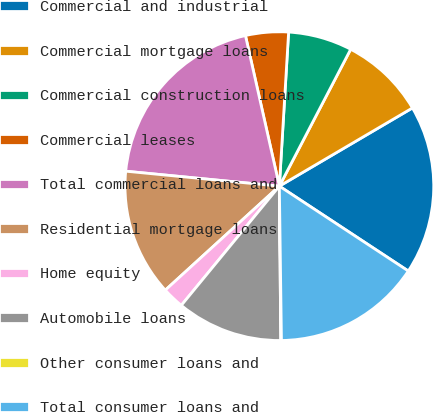<chart> <loc_0><loc_0><loc_500><loc_500><pie_chart><fcel>Commercial and industrial<fcel>Commercial mortgage loans<fcel>Commercial construction loans<fcel>Commercial leases<fcel>Total commercial loans and<fcel>Residential mortgage loans<fcel>Home equity<fcel>Automobile loans<fcel>Other consumer loans and<fcel>Total consumer loans and<nl><fcel>17.72%<fcel>8.9%<fcel>6.69%<fcel>4.48%<fcel>19.93%<fcel>13.31%<fcel>2.28%<fcel>11.1%<fcel>0.07%<fcel>15.52%<nl></chart> 